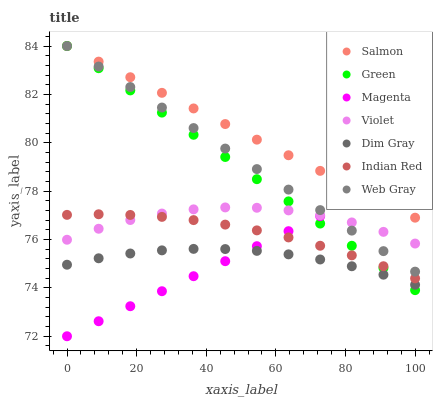Does Dim Gray have the minimum area under the curve?
Answer yes or no. Yes. Does Salmon have the maximum area under the curve?
Answer yes or no. Yes. Does Web Gray have the minimum area under the curve?
Answer yes or no. No. Does Web Gray have the maximum area under the curve?
Answer yes or no. No. Is Magenta the smoothest?
Answer yes or no. Yes. Is Violet the roughest?
Answer yes or no. Yes. Is Salmon the smoothest?
Answer yes or no. No. Is Salmon the roughest?
Answer yes or no. No. Does Magenta have the lowest value?
Answer yes or no. Yes. Does Web Gray have the lowest value?
Answer yes or no. No. Does Green have the highest value?
Answer yes or no. Yes. Does Indian Red have the highest value?
Answer yes or no. No. Is Violet less than Salmon?
Answer yes or no. Yes. Is Web Gray greater than Dim Gray?
Answer yes or no. Yes. Does Green intersect Dim Gray?
Answer yes or no. Yes. Is Green less than Dim Gray?
Answer yes or no. No. Is Green greater than Dim Gray?
Answer yes or no. No. Does Violet intersect Salmon?
Answer yes or no. No. 